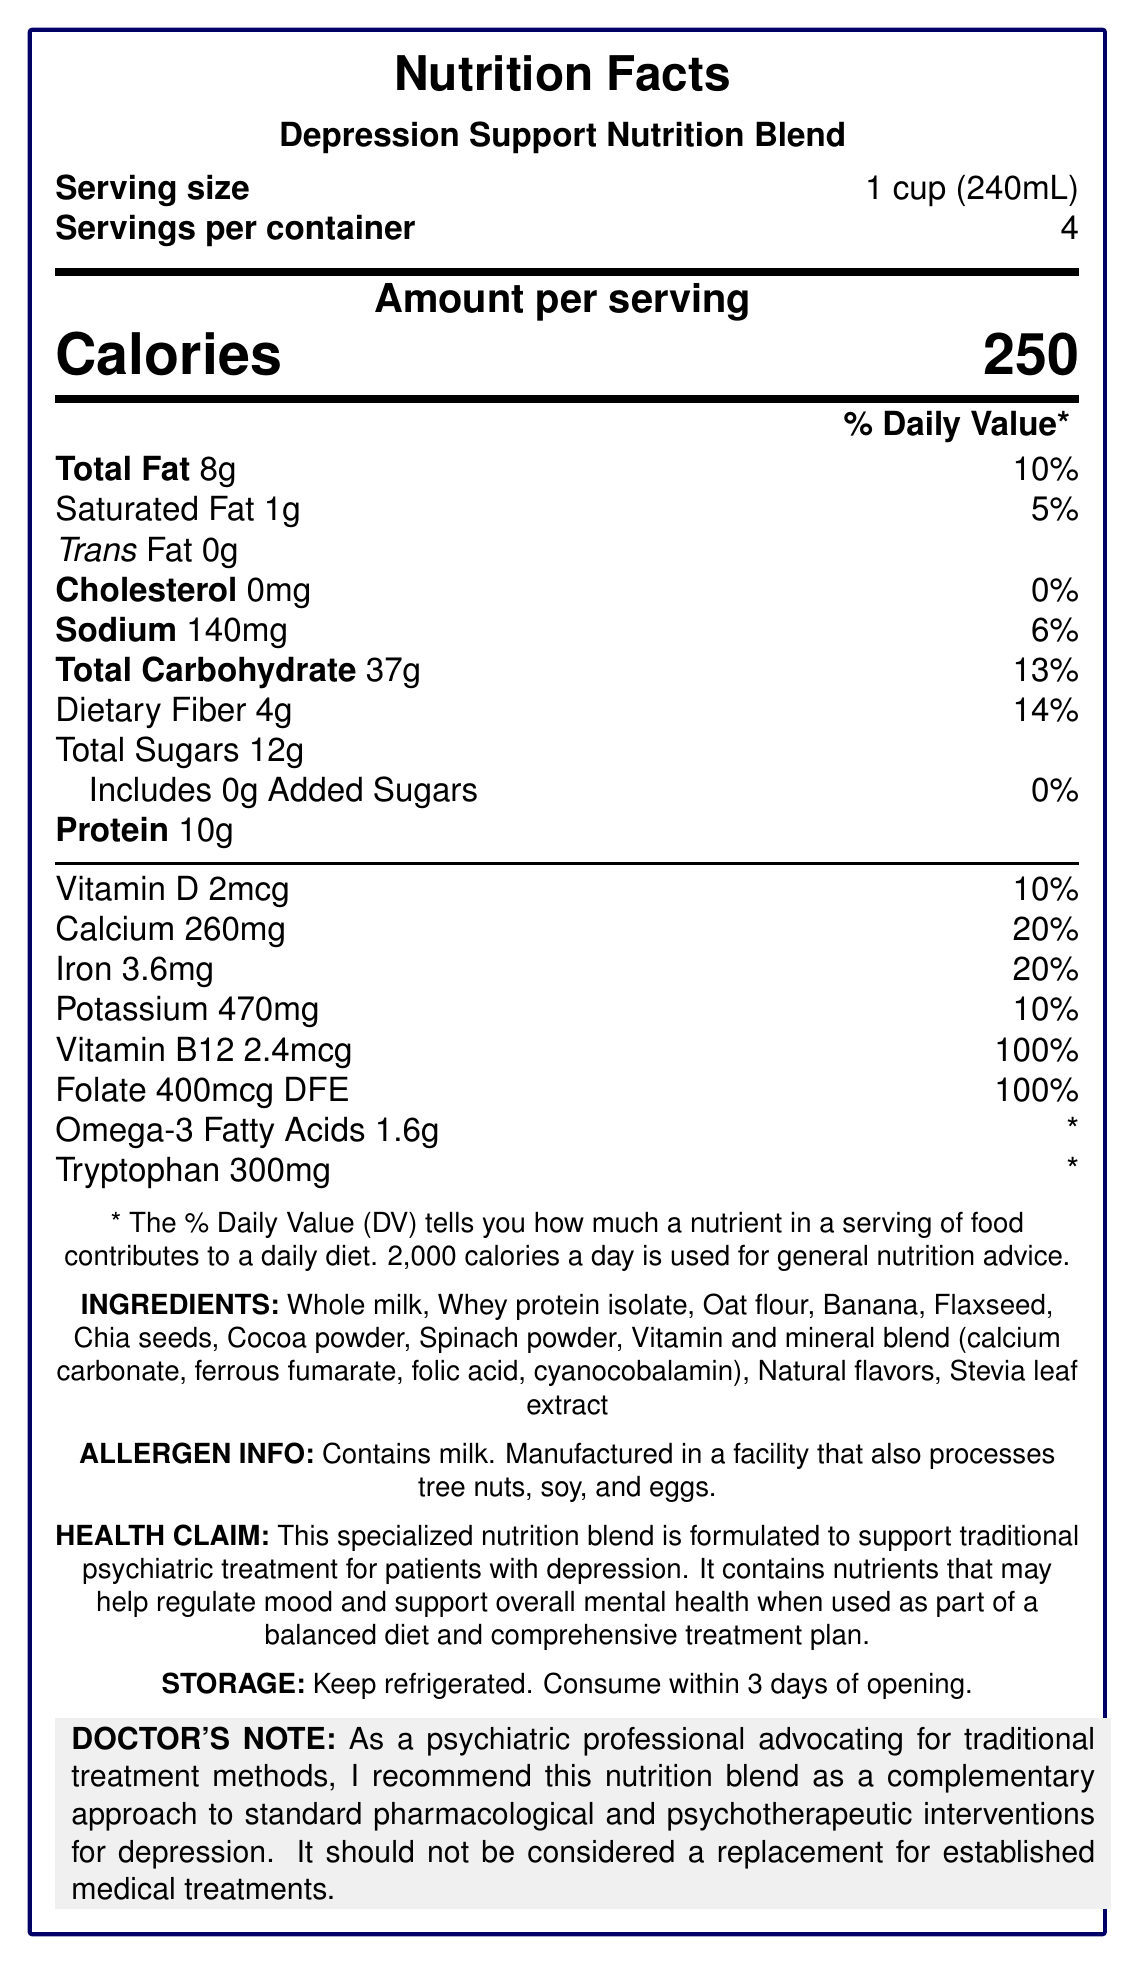what is the serving size of the Depression Support Nutrition Blend? The document lists the serving size as 1 cup (240mL).
Answer: 1 cup (240mL) how many servings per container are there? The document states that there are 4 servings per container.
Answer: 4 how many grams of total fat are in one serving? The document indicates that there are 8 grams of total fat per serving.
Answer: 8g what percentage of the daily value for calcium does one serving contain? The document shows that one serving provides 20% of the daily value for calcium.
Answer: 20% how much protein does one serving contain? The document states that one serving contains 10 grams of protein.
Answer: 10g which ingredient is not included in the Depression Support Nutrition Blend? 
A. Whole milk
B. Soy protein isolate
C. Whey protein isolate
D. Banana The document lists the ingredients, and Soy protein isolate is not included.
Answer: B how should the product be stored after opening? 
A. At room temperature
B. Frozen
C. Keep refrigerated and consume within 3 days
D. Store in a cool, dry place The document specifies that the product should be kept refrigerated and consumed within 3 days of opening.
Answer: C does the product contain any added sugars? The document shows that there are 0 grams of added sugars in the product.
Answer: No is this product intended to replace traditional psychiatric treatments? The doctor's note clearly states that this nutrition blend should not be considered a replacement for established medical treatments.
Answer: No what are the main ingredients included in the Depression Support Nutrition Blend? The document lists these ingredients in the "INGREDIENTS" section.
Answer: Whole milk, Whey protein isolate, Oat flour, Banana, Flaxseed, Chia seeds, Cocoa powder, Spinach powder, Vitamin and mineral blend, Natural flavors, Stevia leaf extract is the Depression Support Nutrition Blend suitable for people with soy allergies? The document only mentions that the product is manufactured in a facility that also processes tree nuts, soy, and eggs, but it doesn't explicitly state whether it is suitable or not for people with soy allergies.
Answer: Cannot be determined what is the main purpose of the Depression Support Nutrition Blend as mentioned in the health claim? The document includes a health claim stating the purpose of the nutrition blend.
Answer: To support traditional psychiatric treatment for patients with depression by providing nutrients that may help regulate mood and support overall mental health when used as part of a balanced diet and comprehensive treatment plan what are the daily values for Vitamin B12 and Folate in one serving? The document lists the daily values for Vitamin B12 and Folate as 100%.
Answer: 100% for both how many calories are in one serving of the Depression Support Nutrition Blend? The document states that there are 250 calories per serving.
Answer: 250 summarize the document. The document gives a comprehensive overview of the Depression Support Nutrition Blend, focusing on its nutritional content and intended use as a complementary support for traditional psychiatric treatment of depression.
Answer: The document provides the nutrition facts and properties of a product called Depression Support Nutrition Blend. It lists the serving size, servings per container, calorie count, and the amount and daily values for various nutrients such as fat, cholesterol, sodium, carbohydrates, protein, vitamins, and minerals. It also includes the ingredients, allergen information, health claims, storage instructions, and a note from a psychiatric doctor emphasizing that the product is a complement to traditional treatments and not a replacement. 